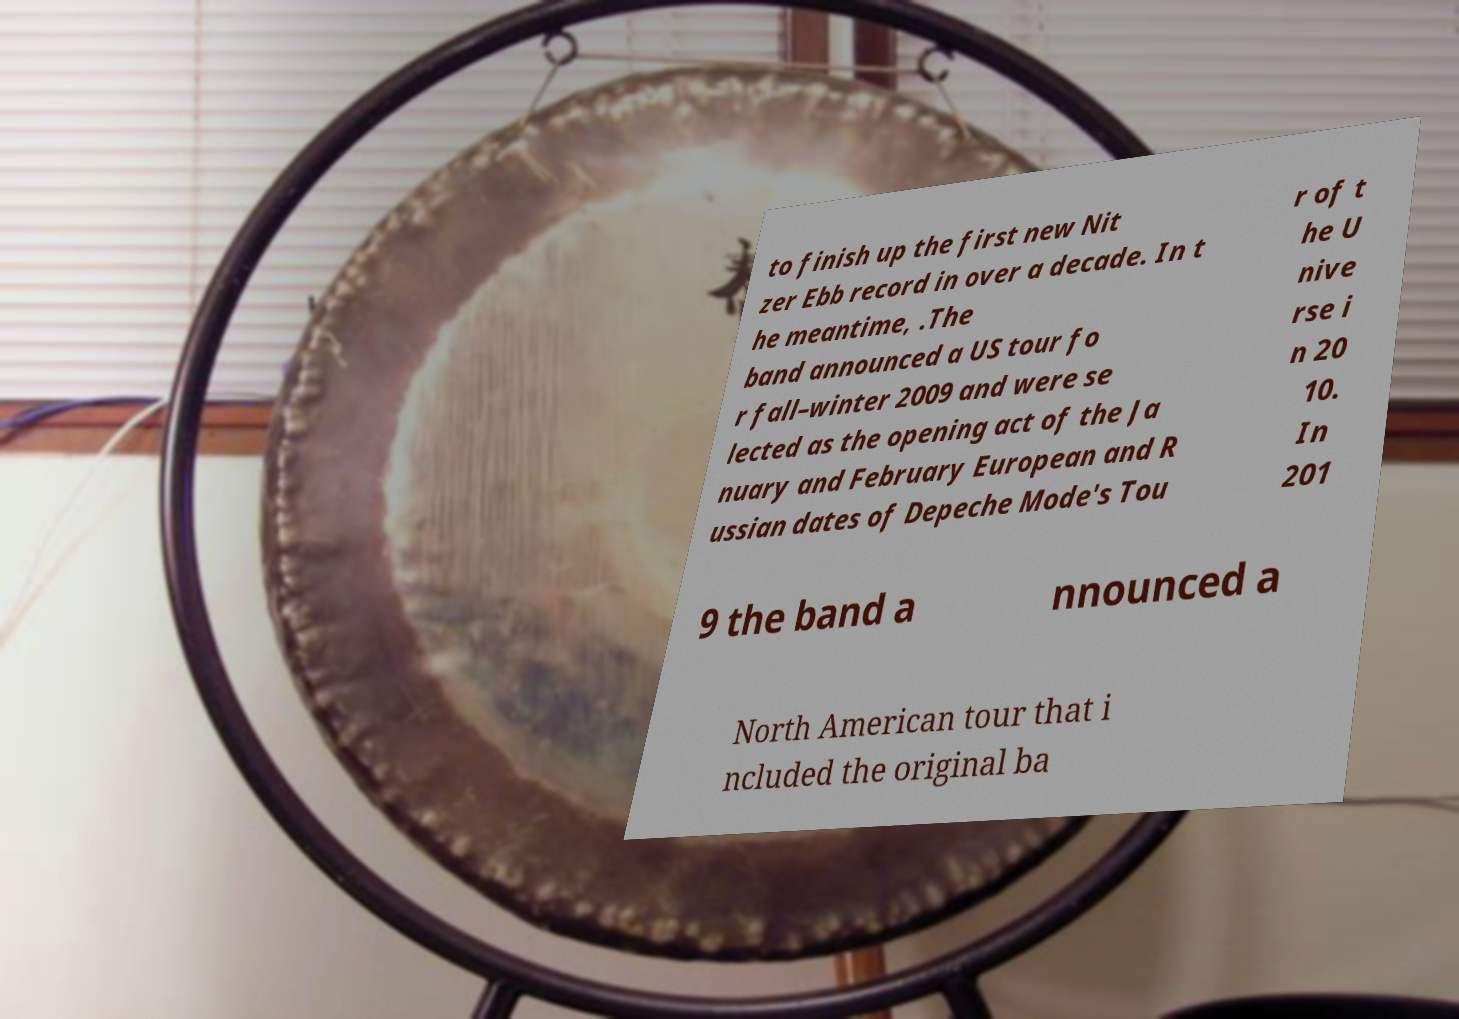There's text embedded in this image that I need extracted. Can you transcribe it verbatim? to finish up the first new Nit zer Ebb record in over a decade. In t he meantime, .The band announced a US tour fo r fall–winter 2009 and were se lected as the opening act of the Ja nuary and February European and R ussian dates of Depeche Mode's Tou r of t he U nive rse i n 20 10. In 201 9 the band a nnounced a North American tour that i ncluded the original ba 